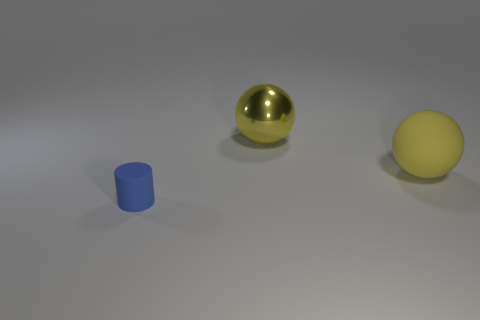There is a yellow thing that is behind the matte object behind the cylinder; what is its shape?
Offer a very short reply. Sphere. Does the large rubber object have the same color as the big shiny object?
Make the answer very short. Yes. There is a thing that is the same size as the metal ball; what shape is it?
Provide a short and direct response. Sphere. How big is the blue matte cylinder?
Keep it short and to the point. Small. There is a yellow matte sphere in front of the big shiny thing; is it the same size as the rubber thing on the left side of the shiny object?
Make the answer very short. No. The big ball that is on the left side of the matte object that is to the right of the tiny blue thing is what color?
Offer a terse response. Yellow. What is the material of the other yellow sphere that is the same size as the yellow metal ball?
Keep it short and to the point. Rubber. How many metallic things are either red cubes or blue things?
Your answer should be compact. 0. What is the color of the thing that is in front of the big metallic sphere and behind the blue object?
Your answer should be compact. Yellow. What number of large yellow things are on the right side of the cylinder?
Provide a short and direct response. 2. 